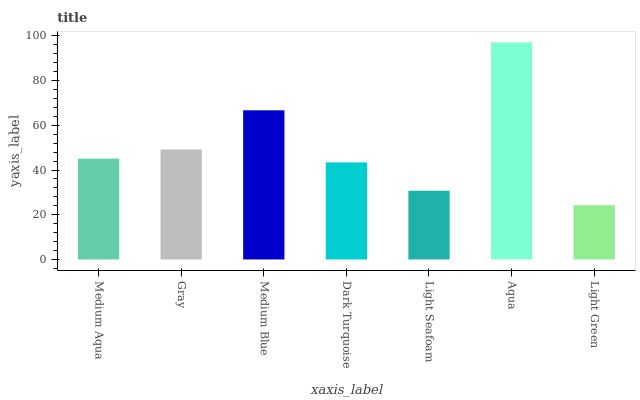Is Light Green the minimum?
Answer yes or no. Yes. Is Aqua the maximum?
Answer yes or no. Yes. Is Gray the minimum?
Answer yes or no. No. Is Gray the maximum?
Answer yes or no. No. Is Gray greater than Medium Aqua?
Answer yes or no. Yes. Is Medium Aqua less than Gray?
Answer yes or no. Yes. Is Medium Aqua greater than Gray?
Answer yes or no. No. Is Gray less than Medium Aqua?
Answer yes or no. No. Is Medium Aqua the high median?
Answer yes or no. Yes. Is Medium Aqua the low median?
Answer yes or no. Yes. Is Light Green the high median?
Answer yes or no. No. Is Light Seafoam the low median?
Answer yes or no. No. 